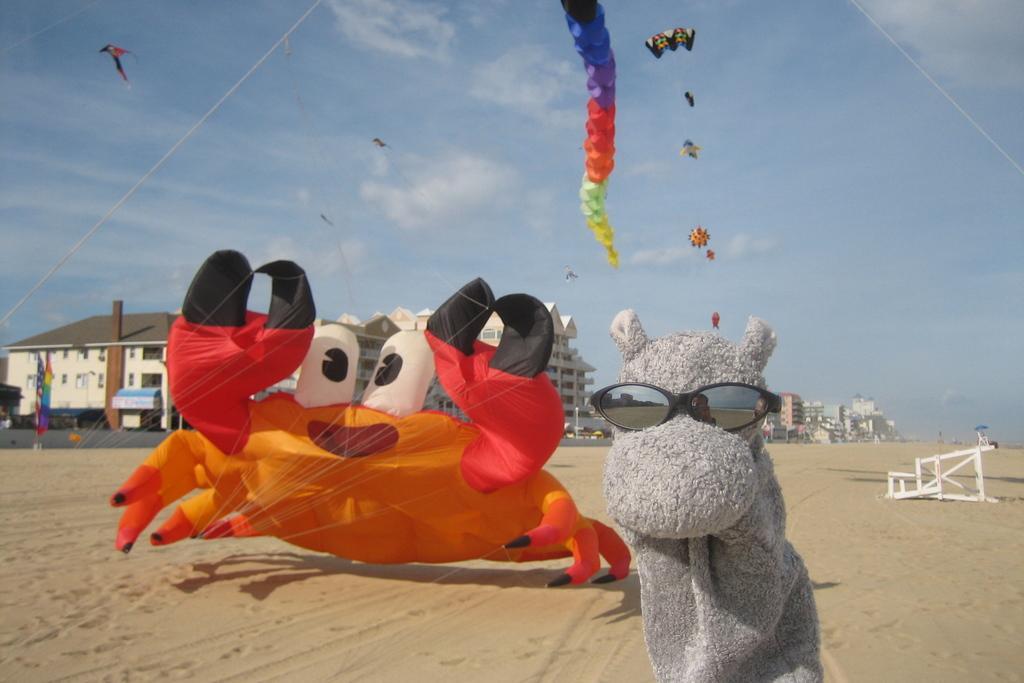In one or two sentences, can you explain what this image depicts? In this image I can see few on the sand, behind them there are so many buildings. 